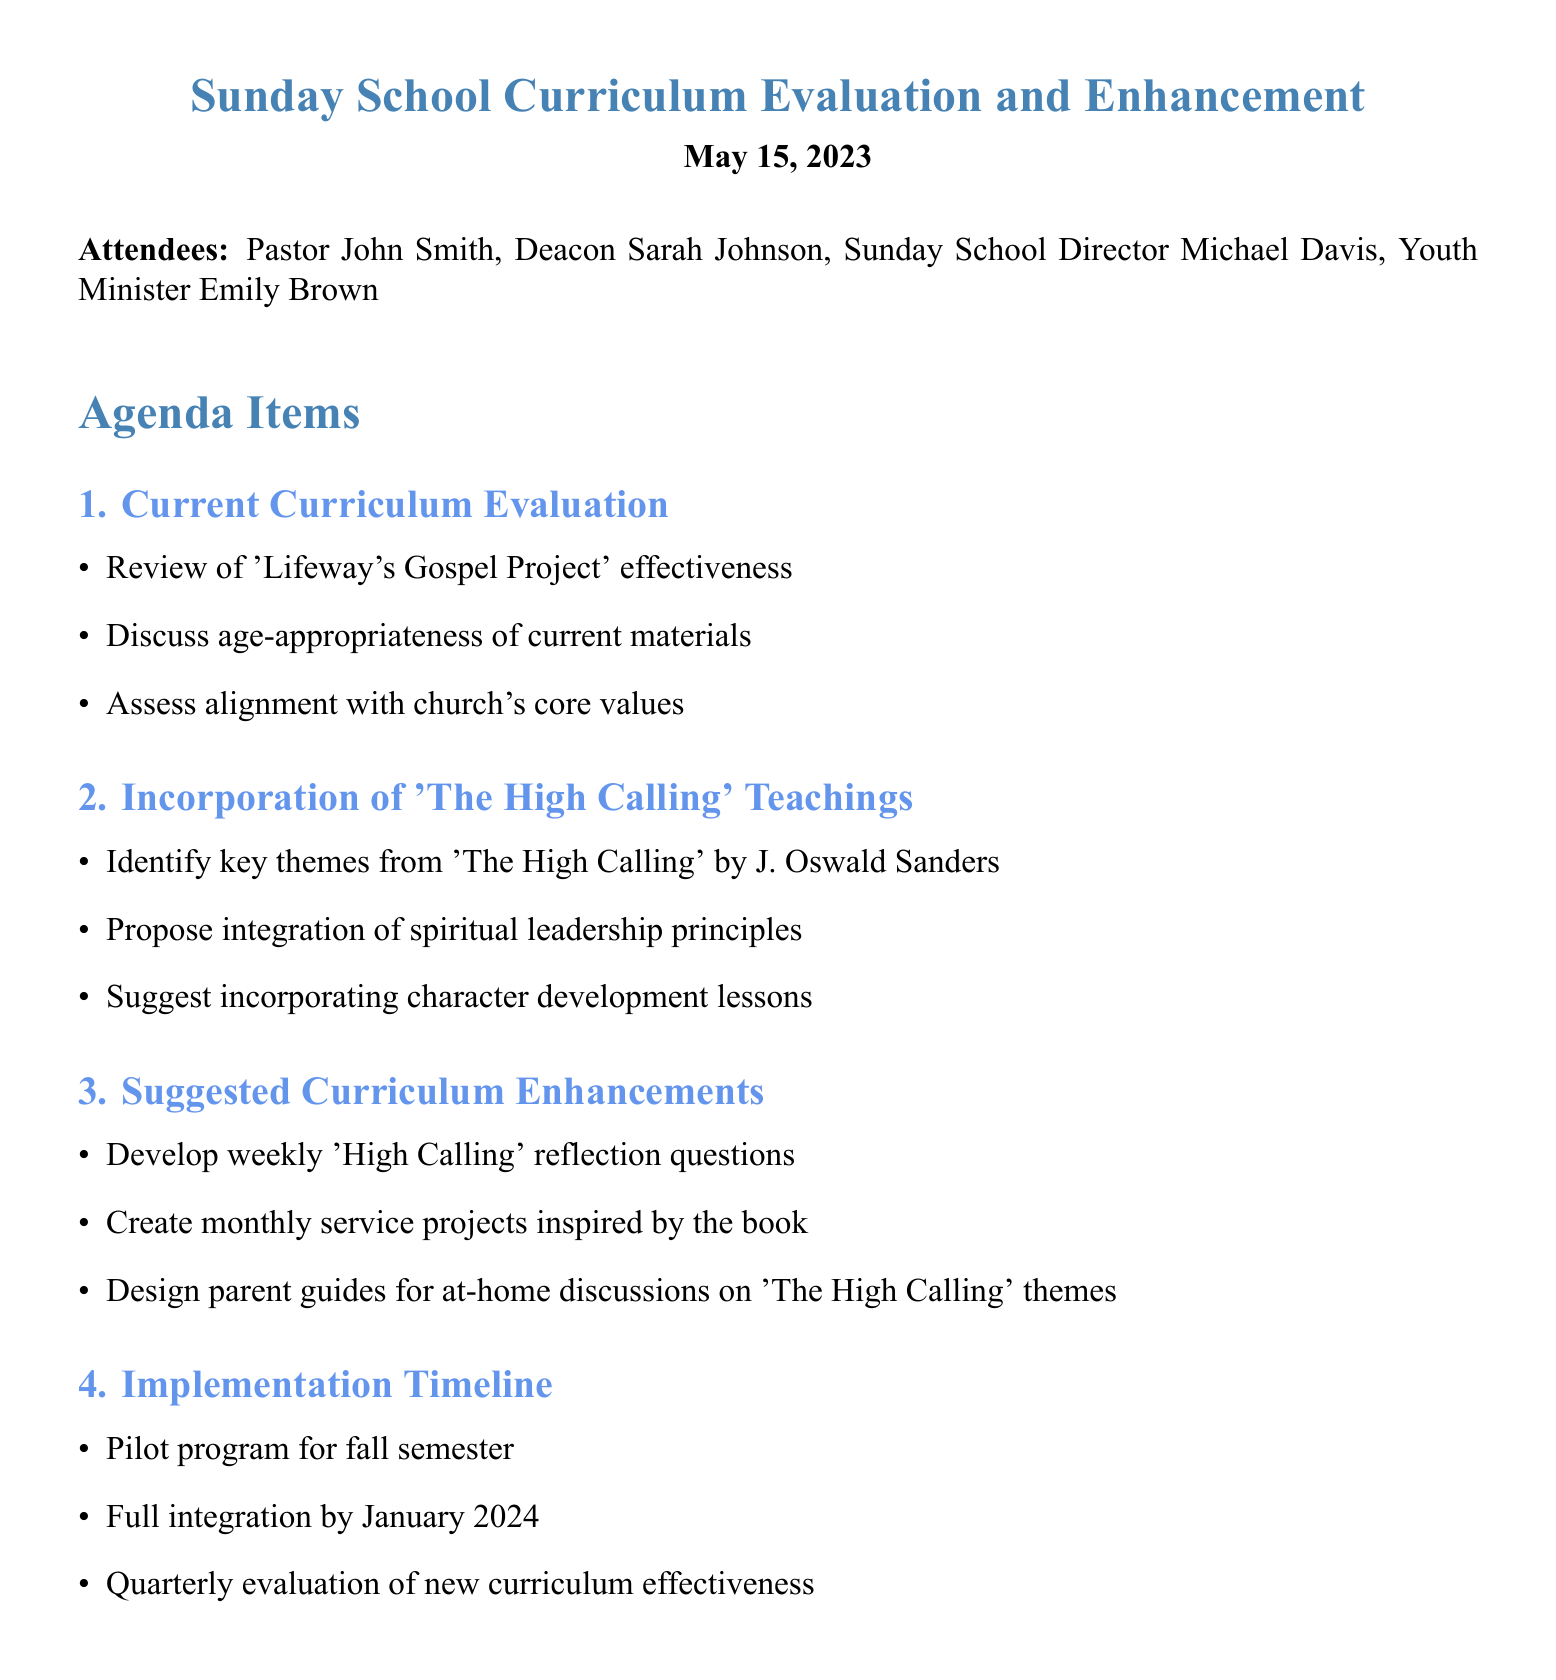What is the date of the meeting? The date of the meeting is stated in the document under the title, which is May 15, 2023.
Answer: May 15, 2023 Who is the Sunday School Director? The name of the Sunday School Director is listed among the attendees of the meeting.
Answer: Michael Davis What is the main agenda topic regarding curriculum enhancement? The document outlines an agenda item specifically for the incorporation of teachings from "The High Calling."
Answer: Incorporation of 'The High Calling' Teachings What is one suggested curriculum enhancement? A bullet point under the Suggested Curriculum Enhancements lists developing weekly reflection questions.
Answer: Develop weekly 'High Calling' reflection questions When is the next meeting scheduled? The next meeting date is provided at the end of the document.
Answer: June 12, 2023 What is the timeline for the pilot program? The timeline mentioned indicates that the pilot program will start in the fall semester.
Answer: Fall semester Which action item is assigned to Michael? The action items section specifies the tasks assigned to each attendee, including drafting lesson plans for Michael.
Answer: Draft new lesson plans incorporating 'The High Calling' themes What is the primary goal of integrating "The High Calling" teachings? The integration focuses on enhancing the spiritual leadership principles in the curriculum.
Answer: Spiritual leadership principles 